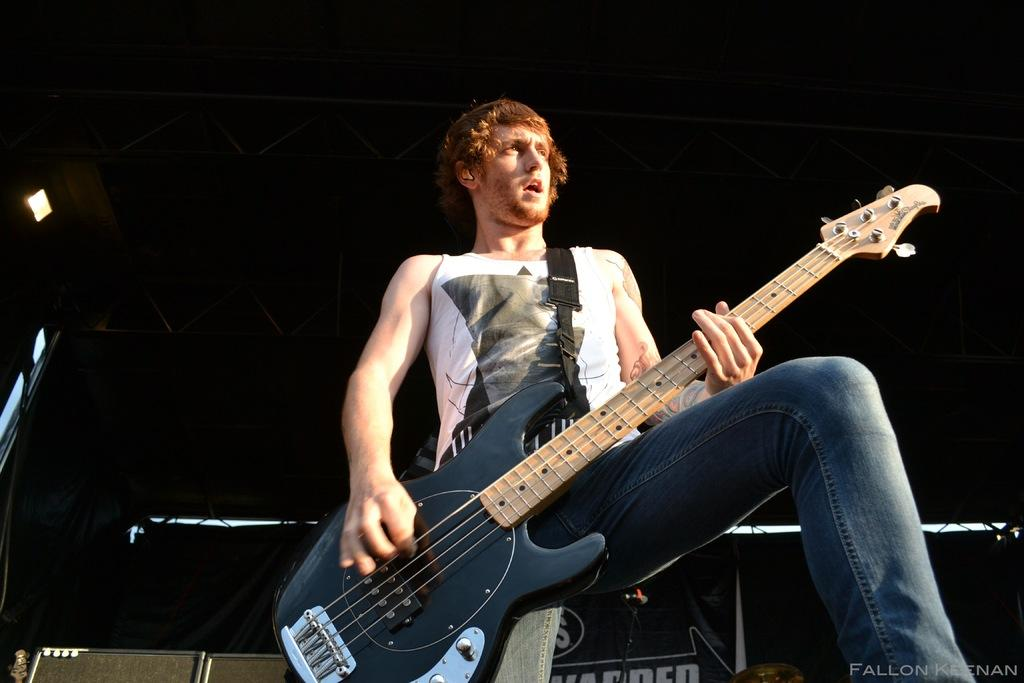Who is present in the image? There is a man in the image. What is the man holding in the image? The man is holding musical instruments. What can be seen in the background of the image? There are grills and electric lights in the background of the image. How many cows are visible in the image? There are no cows present in the image. Can you tell me how many times the man kicks the musical instruments in the image? The man does not kick the musical instruments in the image; he is holding them. 